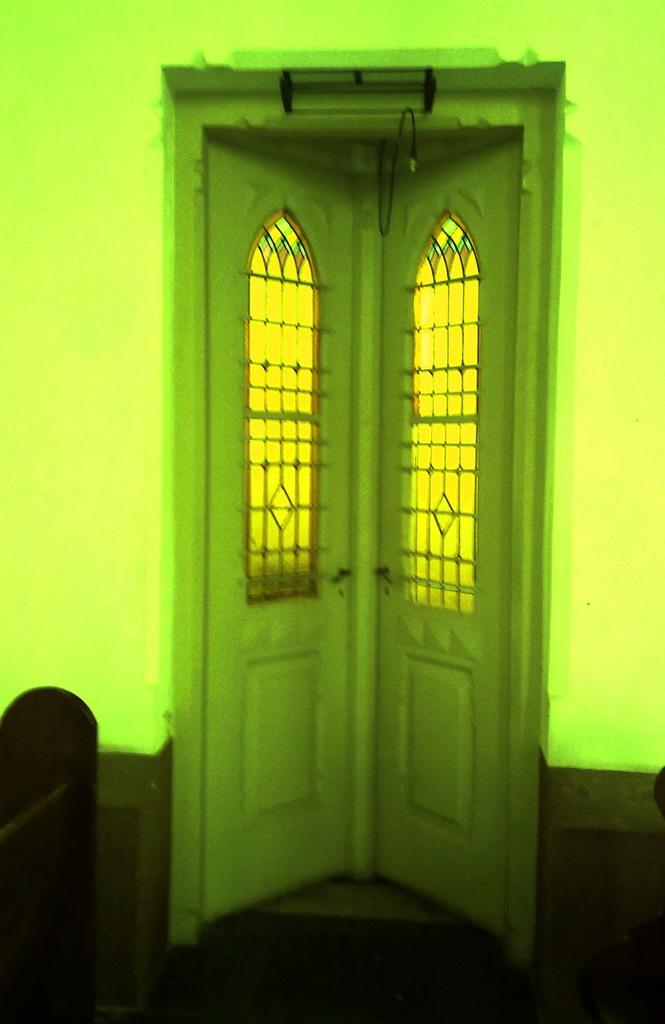What is the main architectural feature in the image? There is a door in the image. What is located beside the door? There is a wall beside the door in the image. Can you describe the wooden object in the image? There is a wooden object in the bottom left of the image. What type of teaching method is being demonstrated in the image? There is no teaching method or activity depicted in the image; it only features a door, a wall, and a wooden object. 